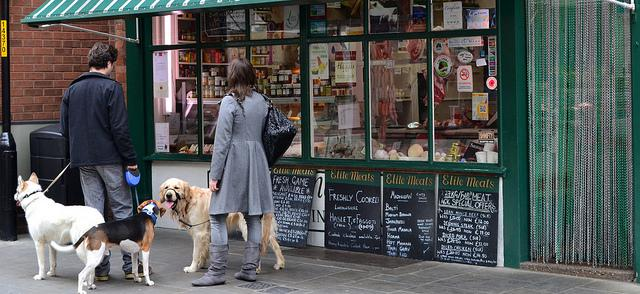What type of animals are shown? Please explain your reasoning. domestic. The dogs are trained. 